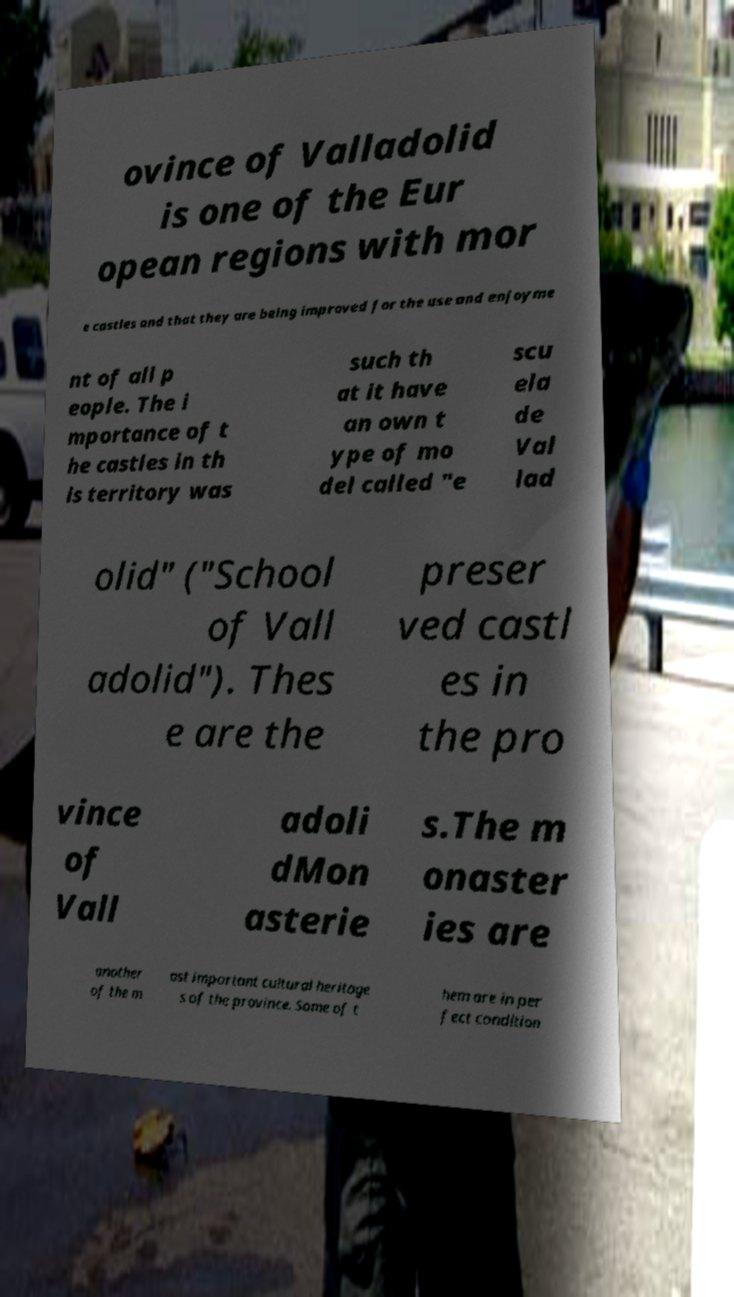Please read and relay the text visible in this image. What does it say? ovince of Valladolid is one of the Eur opean regions with mor e castles and that they are being improved for the use and enjoyme nt of all p eople. The i mportance of t he castles in th is territory was such th at it have an own t ype of mo del called "e scu ela de Val lad olid" ("School of Vall adolid"). Thes e are the preser ved castl es in the pro vince of Vall adoli dMon asterie s.The m onaster ies are another of the m ost important cultural heritage s of the province. Some of t hem are in per fect condition 